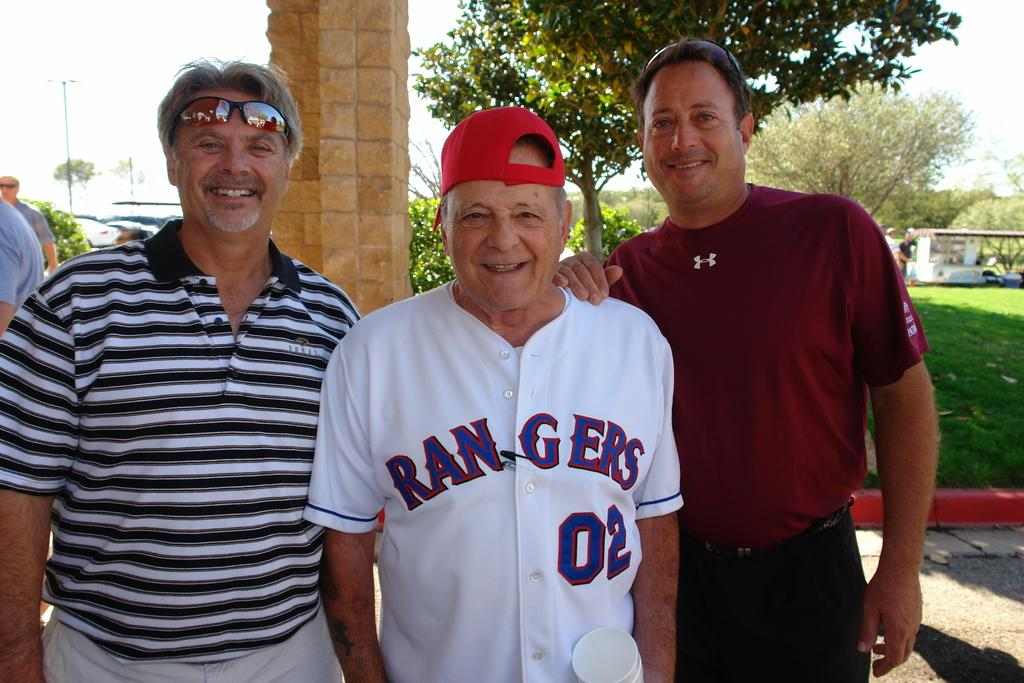Provide a one-sentence caption for the provided image. Three older men are posing for a picture with the man in the middle wearing a RANGERS shirt. 